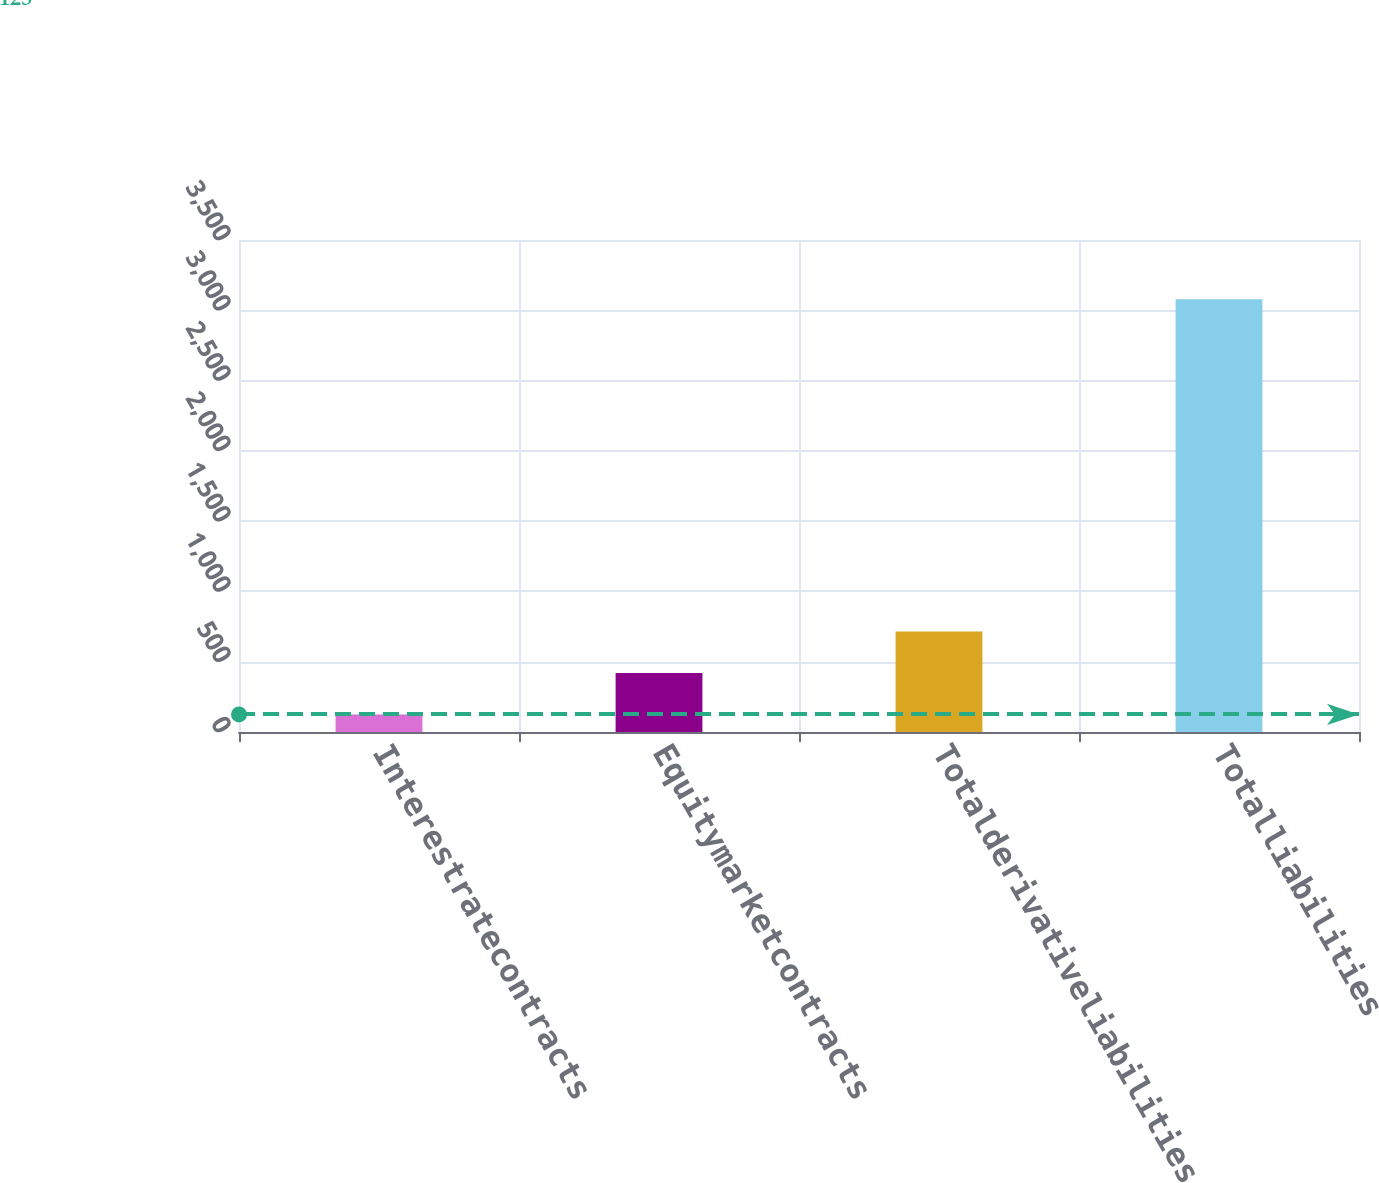Convert chart. <chart><loc_0><loc_0><loc_500><loc_500><bar_chart><fcel>Interestratecontracts<fcel>Equitymarketcontracts<fcel>Totalderivativeliabilities<fcel>Totalliabilities<nl><fcel>125<fcel>420.4<fcel>715.8<fcel>3079<nl></chart> 